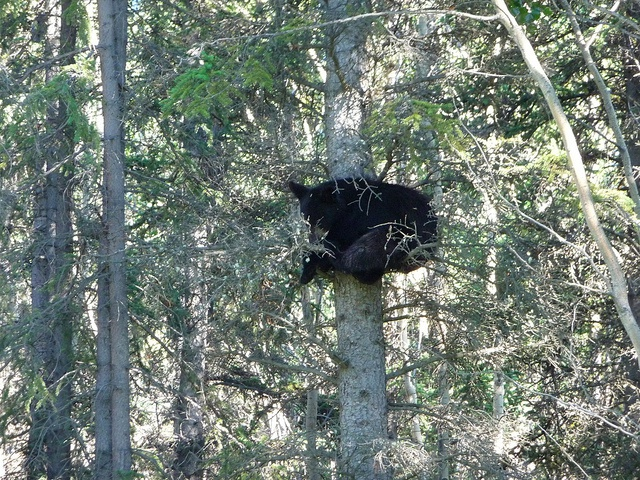Describe the objects in this image and their specific colors. I can see a bear in darkgreen, black, gray, darkgray, and ivory tones in this image. 